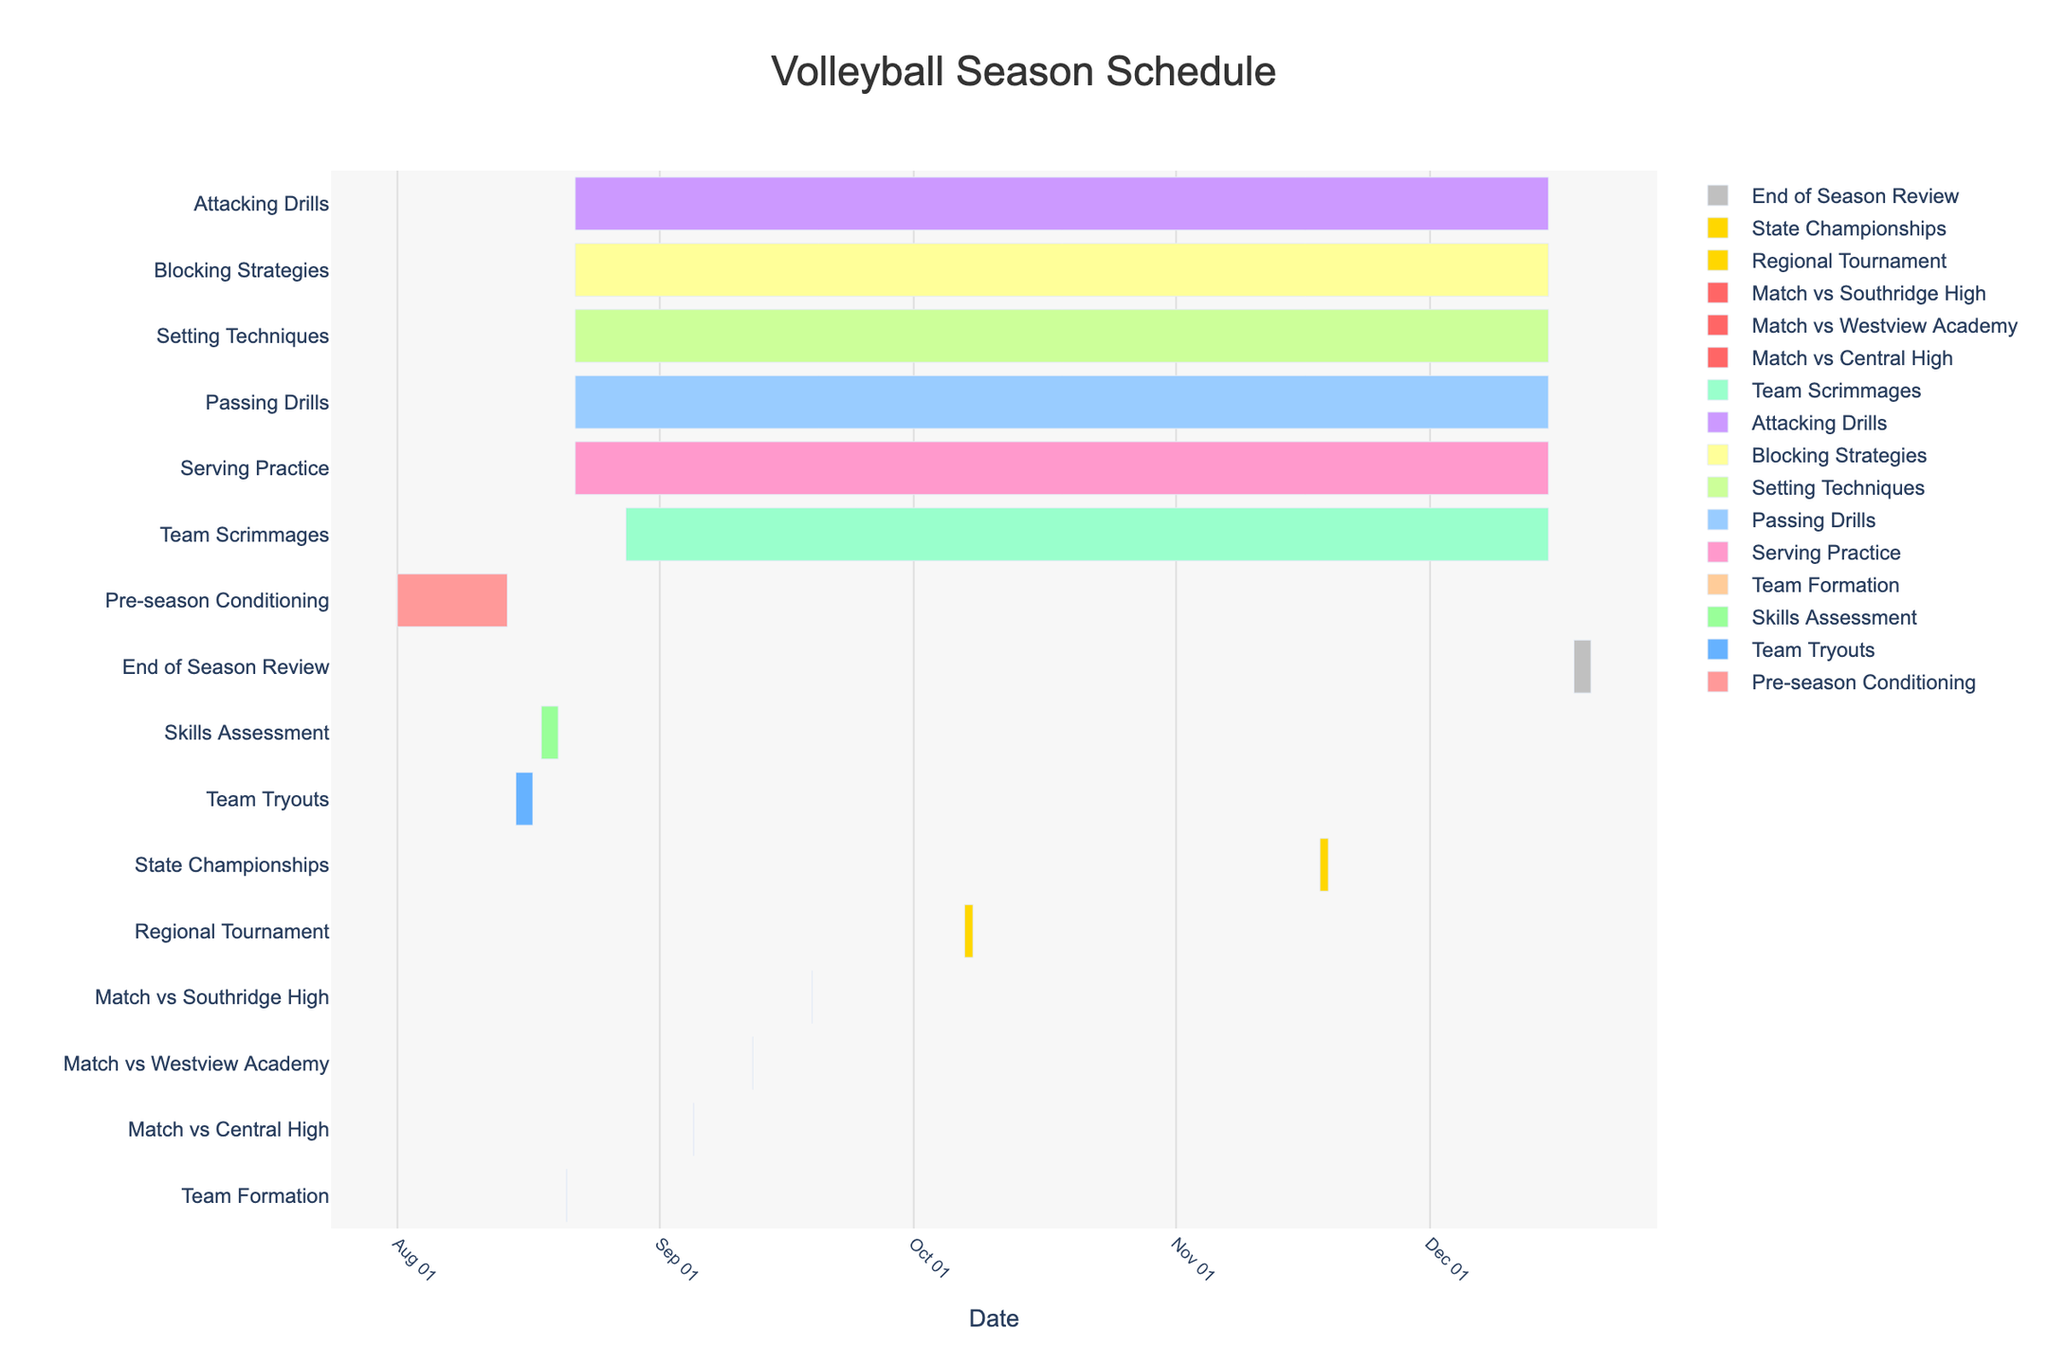what is the title of the chart? The title of the chart is usually found at the top of the figure. It provides a brief description of the purpose or content of the chart.
Answer: Volleyball Season Schedule Which activities last throughout the entire season? To determine which activities span the whole season, we look for the tasks that start at the beginning and end at the final date of practice sessions. Visual inspection helps us recognize these extended activities.
Answer: Serving Practice, Passing Drills, Setting Techniques, Blocking Strategies, Attacking Drills, Team Scrimmages How long is the Pre-season Conditioning period? The Pre-season Conditioning starts on 2023-08-01 and ends on 2023-08-14. By calculating the difference between these dates, we find the duration.
Answer: 14 days When is the Regional Tournament held? The Regional Tournament is shown as a specific task on the chart, with its start and end dates clearly marked.
Answer: October 7 to October 8, 2023 Between “Team Tryouts” and “Skills Assessment,” which one lasts longer? By comparing the start and end dates of both activities, we can see which one has a greater duration. Team Tryouts span from August 15 to August 17, while Skills Assessment spans from August 18 to August 20.
Answer: Skills Assessment What activities take place in November? To find this out, we look at the chart to identify tasks that have any part of their duration within the month of November.
Answer: Serving Practice, Passing Drills, Setting Techniques, Blocking Strategies, Attacking Drills, Team Scrimmages, State Championships What is the time gap between the last match (vs Southridge High) and the Regional Tournament? First, identify the end date of the Match vs Southridge High (September 19, 2023) and the start date of the Regional Tournament (October 7, 2023). Calculate the difference between these dates.
Answer: 18 days How many matches are scheduled before the Regional Tournament? Review the timeline to count the number of "Match" tasks that occur before the Regional Tournament starts.
Answer: 3 matches What is the shortest activity in the entire schedule? Identify the task with the smallest duration by comparing all the start and end dates.
Answer: Team Formation 